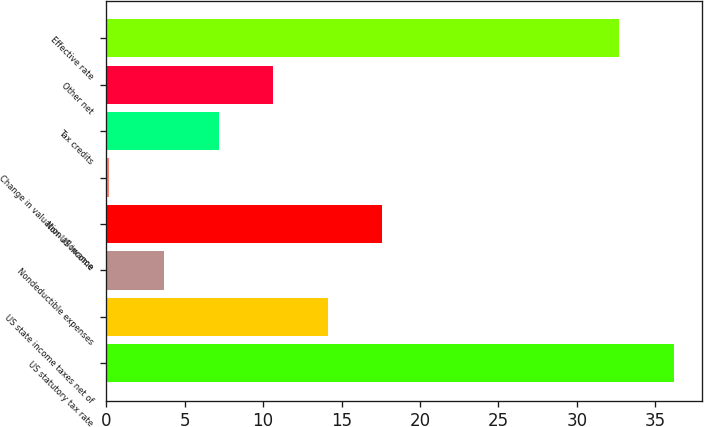Convert chart. <chart><loc_0><loc_0><loc_500><loc_500><bar_chart><fcel>US statutory tax rate<fcel>US state income taxes net of<fcel>Nondeductible expenses<fcel>Non-US income<fcel>Change in valuation allowance<fcel>Tax credits<fcel>Other net<fcel>Effective rate<nl><fcel>36.18<fcel>14.12<fcel>3.68<fcel>17.6<fcel>0.2<fcel>7.16<fcel>10.64<fcel>32.7<nl></chart> 